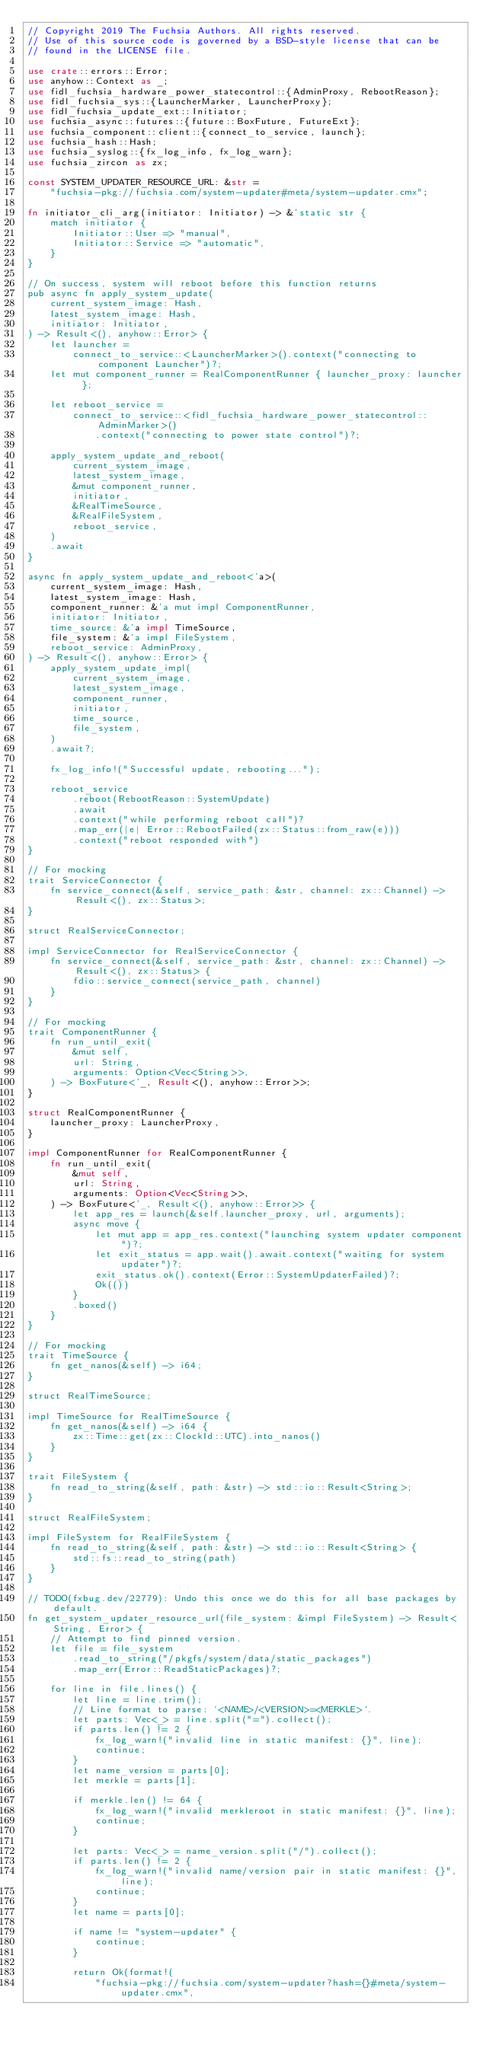Convert code to text. <code><loc_0><loc_0><loc_500><loc_500><_Rust_>// Copyright 2019 The Fuchsia Authors. All rights reserved.
// Use of this source code is governed by a BSD-style license that can be
// found in the LICENSE file.

use crate::errors::Error;
use anyhow::Context as _;
use fidl_fuchsia_hardware_power_statecontrol::{AdminProxy, RebootReason};
use fidl_fuchsia_sys::{LauncherMarker, LauncherProxy};
use fidl_fuchsia_update_ext::Initiator;
use fuchsia_async::futures::{future::BoxFuture, FutureExt};
use fuchsia_component::client::{connect_to_service, launch};
use fuchsia_hash::Hash;
use fuchsia_syslog::{fx_log_info, fx_log_warn};
use fuchsia_zircon as zx;

const SYSTEM_UPDATER_RESOURCE_URL: &str =
    "fuchsia-pkg://fuchsia.com/system-updater#meta/system-updater.cmx";

fn initiator_cli_arg(initiator: Initiator) -> &'static str {
    match initiator {
        Initiator::User => "manual",
        Initiator::Service => "automatic",
    }
}

// On success, system will reboot before this function returns
pub async fn apply_system_update(
    current_system_image: Hash,
    latest_system_image: Hash,
    initiator: Initiator,
) -> Result<(), anyhow::Error> {
    let launcher =
        connect_to_service::<LauncherMarker>().context("connecting to component Launcher")?;
    let mut component_runner = RealComponentRunner { launcher_proxy: launcher };

    let reboot_service =
        connect_to_service::<fidl_fuchsia_hardware_power_statecontrol::AdminMarker>()
            .context("connecting to power state control")?;

    apply_system_update_and_reboot(
        current_system_image,
        latest_system_image,
        &mut component_runner,
        initiator,
        &RealTimeSource,
        &RealFileSystem,
        reboot_service,
    )
    .await
}

async fn apply_system_update_and_reboot<'a>(
    current_system_image: Hash,
    latest_system_image: Hash,
    component_runner: &'a mut impl ComponentRunner,
    initiator: Initiator,
    time_source: &'a impl TimeSource,
    file_system: &'a impl FileSystem,
    reboot_service: AdminProxy,
) -> Result<(), anyhow::Error> {
    apply_system_update_impl(
        current_system_image,
        latest_system_image,
        component_runner,
        initiator,
        time_source,
        file_system,
    )
    .await?;

    fx_log_info!("Successful update, rebooting...");

    reboot_service
        .reboot(RebootReason::SystemUpdate)
        .await
        .context("while performing reboot call")?
        .map_err(|e| Error::RebootFailed(zx::Status::from_raw(e)))
        .context("reboot responded with")
}

// For mocking
trait ServiceConnector {
    fn service_connect(&self, service_path: &str, channel: zx::Channel) -> Result<(), zx::Status>;
}

struct RealServiceConnector;

impl ServiceConnector for RealServiceConnector {
    fn service_connect(&self, service_path: &str, channel: zx::Channel) -> Result<(), zx::Status> {
        fdio::service_connect(service_path, channel)
    }
}

// For mocking
trait ComponentRunner {
    fn run_until_exit(
        &mut self,
        url: String,
        arguments: Option<Vec<String>>,
    ) -> BoxFuture<'_, Result<(), anyhow::Error>>;
}

struct RealComponentRunner {
    launcher_proxy: LauncherProxy,
}

impl ComponentRunner for RealComponentRunner {
    fn run_until_exit(
        &mut self,
        url: String,
        arguments: Option<Vec<String>>,
    ) -> BoxFuture<'_, Result<(), anyhow::Error>> {
        let app_res = launch(&self.launcher_proxy, url, arguments);
        async move {
            let mut app = app_res.context("launching system updater component")?;
            let exit_status = app.wait().await.context("waiting for system updater")?;
            exit_status.ok().context(Error::SystemUpdaterFailed)?;
            Ok(())
        }
        .boxed()
    }
}

// For mocking
trait TimeSource {
    fn get_nanos(&self) -> i64;
}

struct RealTimeSource;

impl TimeSource for RealTimeSource {
    fn get_nanos(&self) -> i64 {
        zx::Time::get(zx::ClockId::UTC).into_nanos()
    }
}

trait FileSystem {
    fn read_to_string(&self, path: &str) -> std::io::Result<String>;
}

struct RealFileSystem;

impl FileSystem for RealFileSystem {
    fn read_to_string(&self, path: &str) -> std::io::Result<String> {
        std::fs::read_to_string(path)
    }
}

// TODO(fxbug.dev/22779): Undo this once we do this for all base packages by default.
fn get_system_updater_resource_url(file_system: &impl FileSystem) -> Result<String, Error> {
    // Attempt to find pinned version.
    let file = file_system
        .read_to_string("/pkgfs/system/data/static_packages")
        .map_err(Error::ReadStaticPackages)?;

    for line in file.lines() {
        let line = line.trim();
        // Line format to parse: `<NAME>/<VERSION>=<MERKLE>`.
        let parts: Vec<_> = line.split("=").collect();
        if parts.len() != 2 {
            fx_log_warn!("invalid line in static manifest: {}", line);
            continue;
        }
        let name_version = parts[0];
        let merkle = parts[1];

        if merkle.len() != 64 {
            fx_log_warn!("invalid merkleroot in static manifest: {}", line);
            continue;
        }

        let parts: Vec<_> = name_version.split("/").collect();
        if parts.len() != 2 {
            fx_log_warn!("invalid name/version pair in static manifest: {}", line);
            continue;
        }
        let name = parts[0];

        if name != "system-updater" {
            continue;
        }

        return Ok(format!(
            "fuchsia-pkg://fuchsia.com/system-updater?hash={}#meta/system-updater.cmx",</code> 